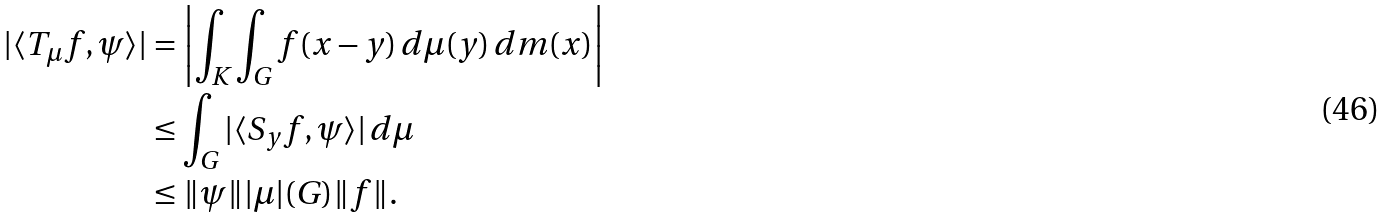Convert formula to latex. <formula><loc_0><loc_0><loc_500><loc_500>| \langle T _ { \mu } f , \psi \rangle | & = \left | \int _ { K } \int _ { G } f ( x - y ) \, d \mu ( y ) \, d m ( x ) \right | \\ & \leq \int _ { G } | \langle S _ { y } f , \psi \rangle | \, d \mu \\ & \leq \| \psi \| | \mu | ( G ) \| f \| .</formula> 